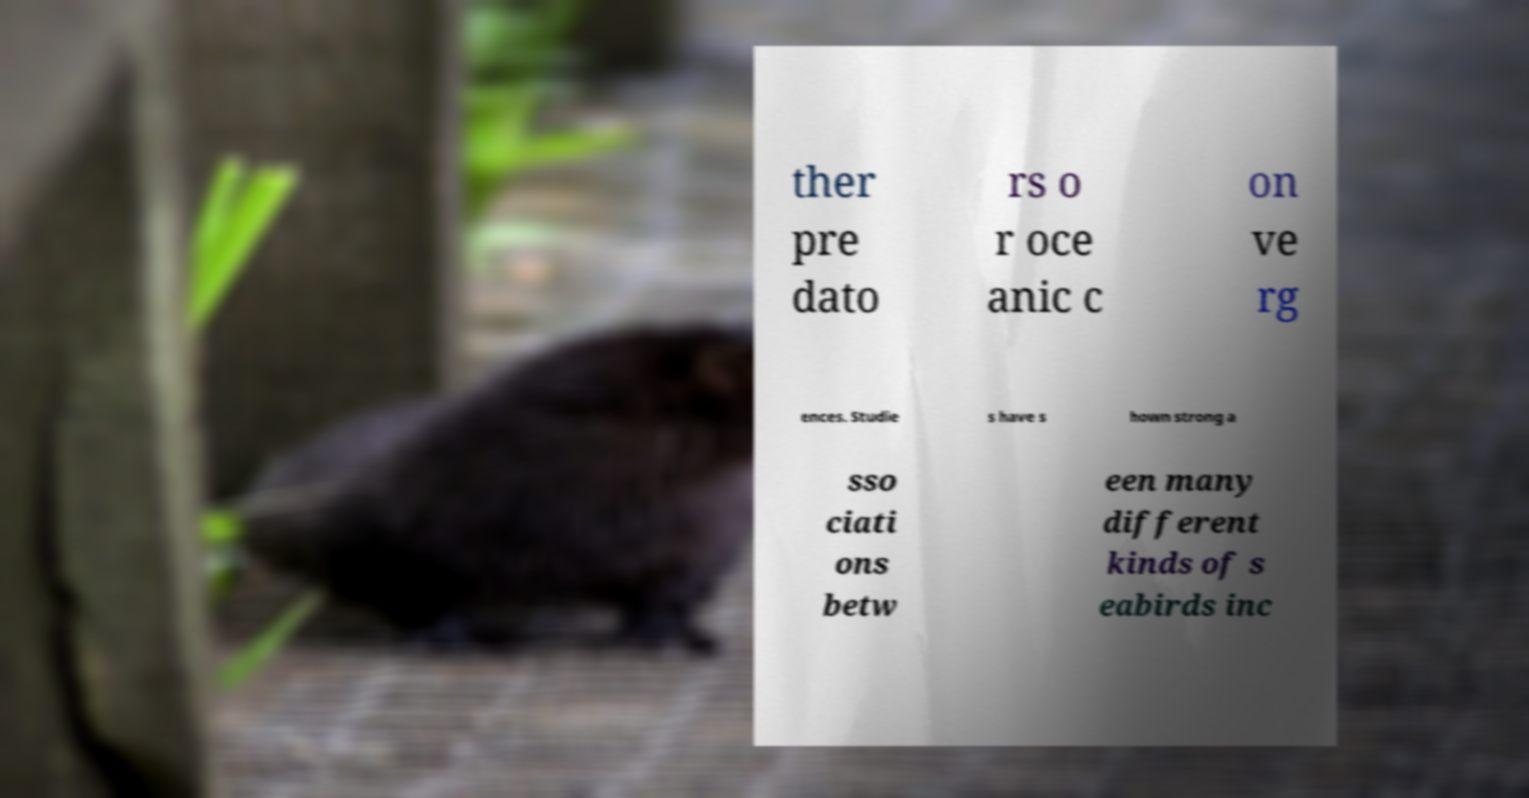Please identify and transcribe the text found in this image. ther pre dato rs o r oce anic c on ve rg ences. Studie s have s hown strong a sso ciati ons betw een many different kinds of s eabirds inc 